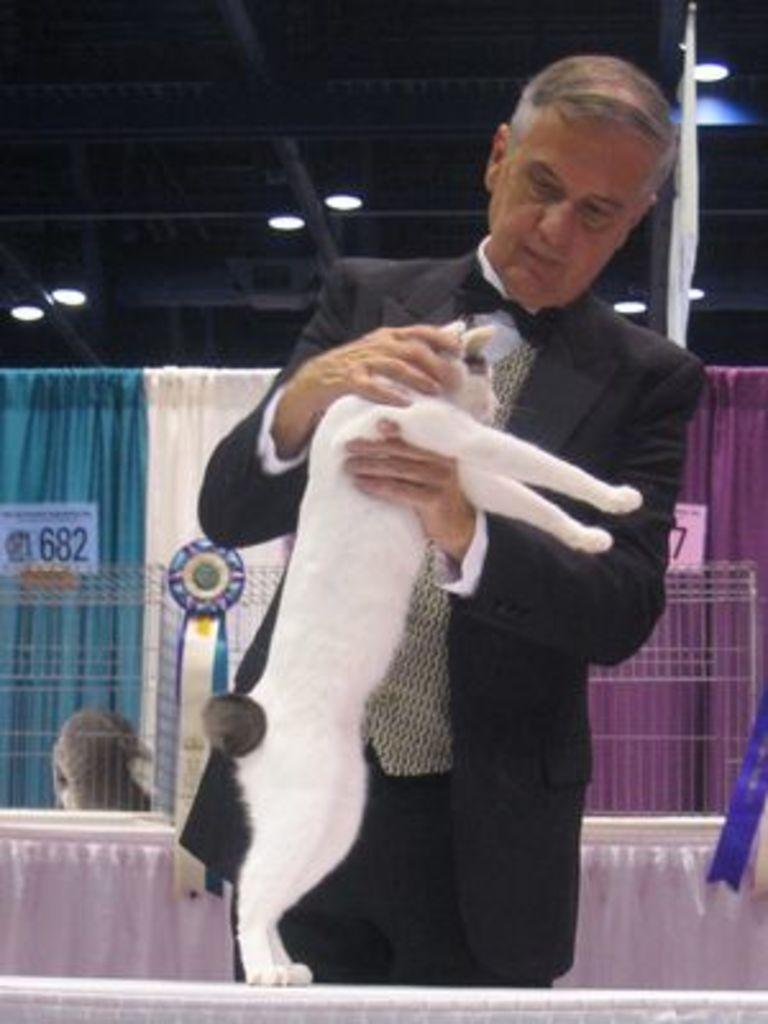How would you summarize this image in a sentence or two? In the middle of the image a man is standing and holding a cat. Behind him there is a banner. Top of the image there is a roof and lights. 